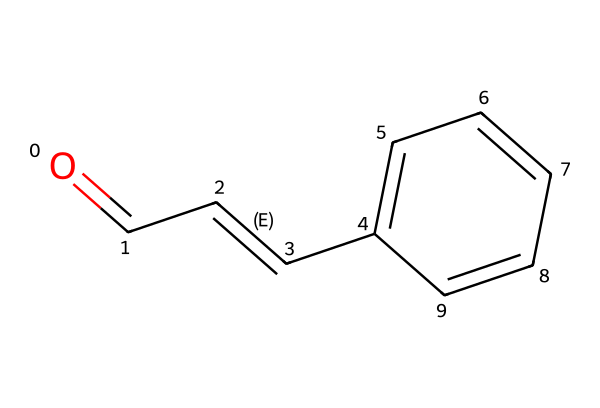What is the IUPAC name of this compound? The compound has a functional group indicated by "O=C" (which denotes the carbonyl group) followed by the trans double bond "/C=C/" and an aromatic ring "c1ccccc1". The correct IUPAC name, therefore, is cinnamaldehyde.
Answer: cinnamaldehyde How many double bonds are present in this structure? By analyzing the SMILES, we recognize that there is one double bond between the carbon atoms indicated by "/C=C/", therefore the structure contains one double bond.
Answer: one What functional group is present in cinnamaldehyde? The presence of "O=C" in the SMILES structure shows that the compound includes a carbonyl group (aldehyde). Hence, the functional group is aldehyde.
Answer: aldehyde How many geometric isomers can be formed from this compound? Since the compound has one double bond leading to possible isomerization, it can form two distinct geometric isomers, which correspond to the cis and trans configurations around that double bond.
Answer: two Which is the more stable geometric isomer of cinnamaldehyde? The trans isomer is generally more stable than the cis isomer due to reduced steric hindrance between substituents on the double bond. This stability arises from the more favorable spatial arrangement of the larger groups on opposite sides.
Answer: trans Identify the source of the aromatic property in this compound. The component "c1ccccc1" in the SMILES denotes a benzene ring, which is a cyclic structure with alternating double bonds that contributes to its aromatic character.
Answer: benzene ring 